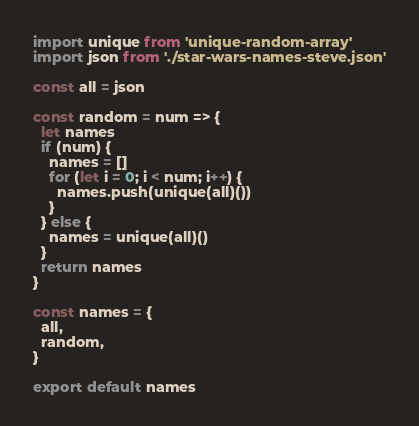Convert code to text. <code><loc_0><loc_0><loc_500><loc_500><_JavaScript_>import unique from 'unique-random-array'
import json from './star-wars-names-steve.json'

const all = json

const random = num => {
  let names
  if (num) {
    names = []
    for (let i = 0; i < num; i++) {
      names.push(unique(all)())
    }
  } else {
    names = unique(all)()
  }
  return names
}

const names = {
  all,
  random,
}

export default names
</code> 